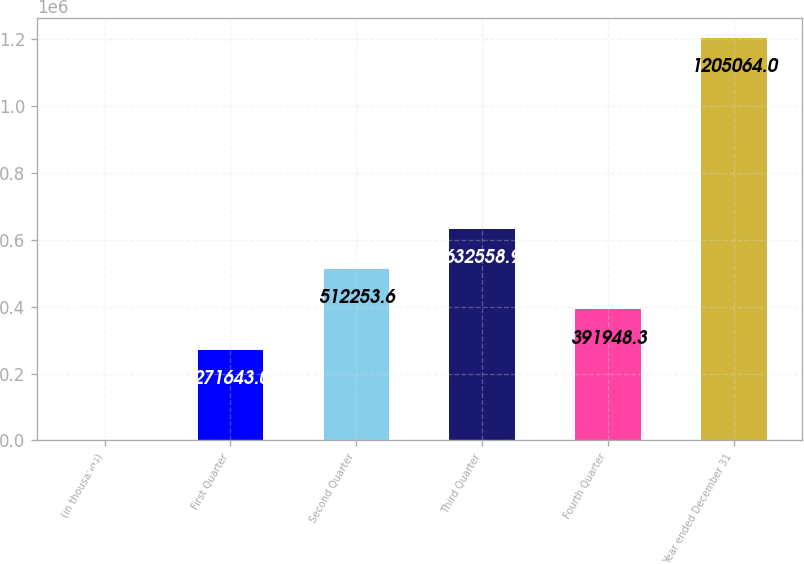Convert chart to OTSL. <chart><loc_0><loc_0><loc_500><loc_500><bar_chart><fcel>(in thousands)<fcel>First Quarter<fcel>Second Quarter<fcel>Third Quarter<fcel>Fourth Quarter<fcel>Year ended December 31<nl><fcel>2011<fcel>271643<fcel>512254<fcel>632559<fcel>391948<fcel>1.20506e+06<nl></chart> 